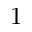<formula> <loc_0><loc_0><loc_500><loc_500>1</formula> 